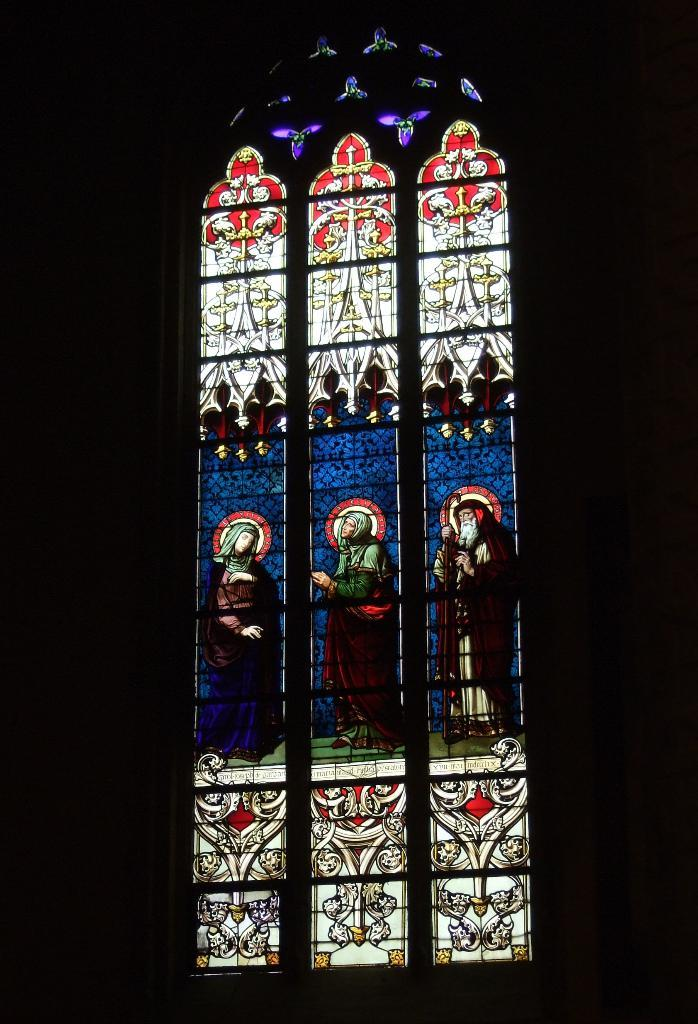What can be seen on a vertical surface in the image? There is a window on a wall in the image. What is depicted on the window? The window has a painting of a few persons on it. Are there any additional decorative elements on the window? Yes, there are designs on the window. How many pigs can be seen in the image? There are no pigs present in the image; the painting on the window features a few persons. 